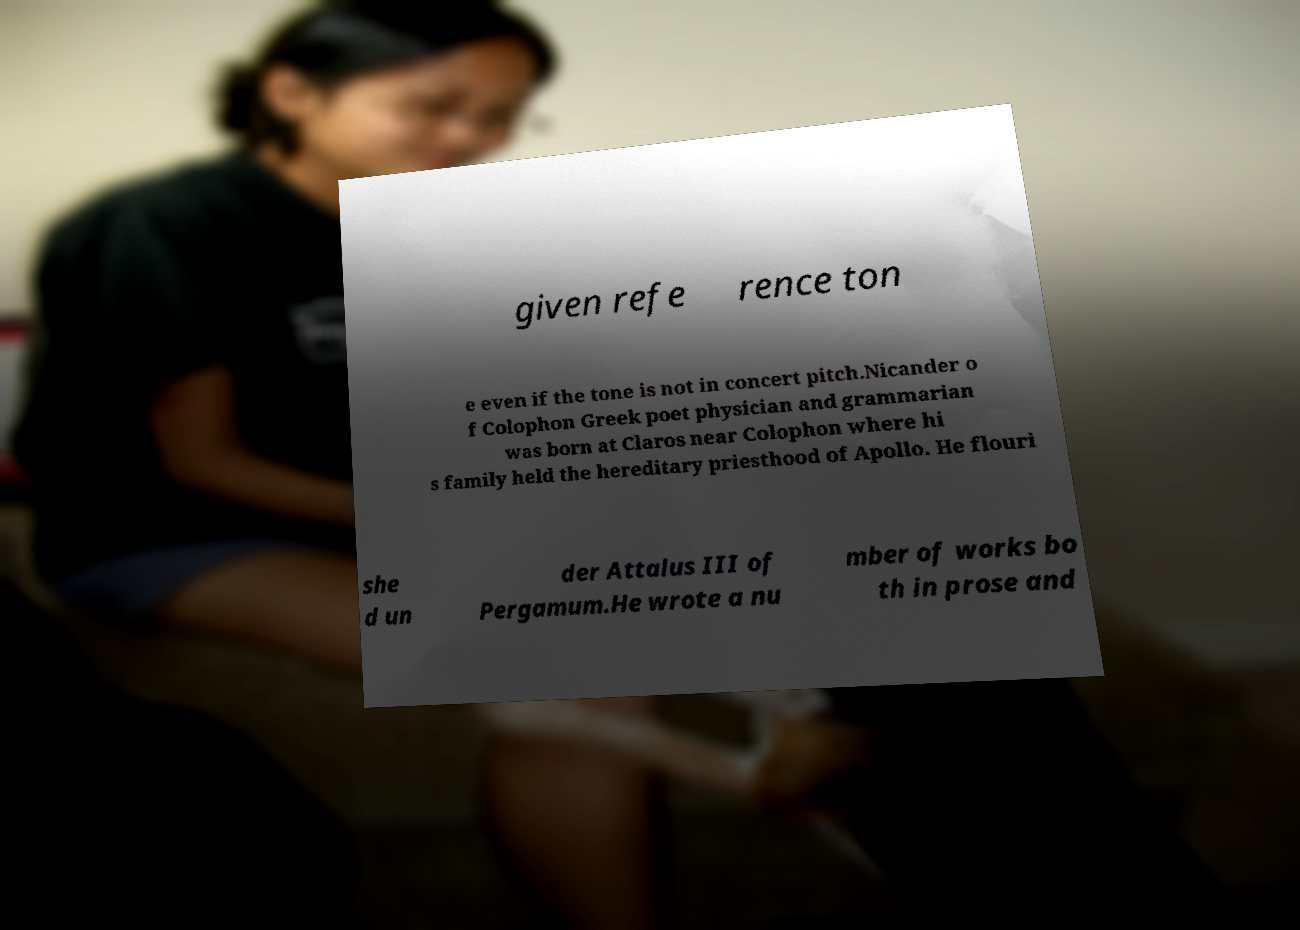Can you accurately transcribe the text from the provided image for me? given refe rence ton e even if the tone is not in concert pitch.Nicander o f Colophon Greek poet physician and grammarian was born at Claros near Colophon where hi s family held the hereditary priesthood of Apollo. He flouri she d un der Attalus III of Pergamum.He wrote a nu mber of works bo th in prose and 